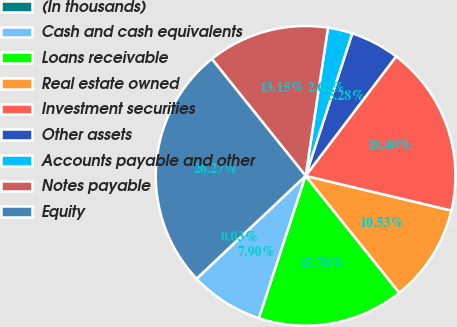Convert chart. <chart><loc_0><loc_0><loc_500><loc_500><pie_chart><fcel>(In thousands)<fcel>Cash and cash equivalents<fcel>Loans receivable<fcel>Real estate owned<fcel>Investment securities<fcel>Other assets<fcel>Accounts payable and other<fcel>Notes payable<fcel>Equity<nl><fcel>0.03%<fcel>7.9%<fcel>15.78%<fcel>10.53%<fcel>18.4%<fcel>5.28%<fcel>2.65%<fcel>13.15%<fcel>26.27%<nl></chart> 